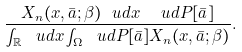<formula> <loc_0><loc_0><loc_500><loc_500>\frac { X _ { n } ( x , \bar { a } ; \beta ) \ u d x \ \ u d P [ \bar { a } ] } { \int _ { \mathbb { R } } \ u d x \int _ { \Omega } \ u d P [ \bar { a } ] X _ { n } ( x , \bar { a } ; \beta ) } .</formula> 